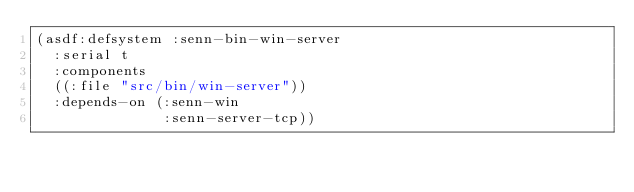Convert code to text. <code><loc_0><loc_0><loc_500><loc_500><_Lisp_>(asdf:defsystem :senn-bin-win-server
  :serial t
  :components
  ((:file "src/bin/win-server"))
  :depends-on (:senn-win
               :senn-server-tcp))
</code> 